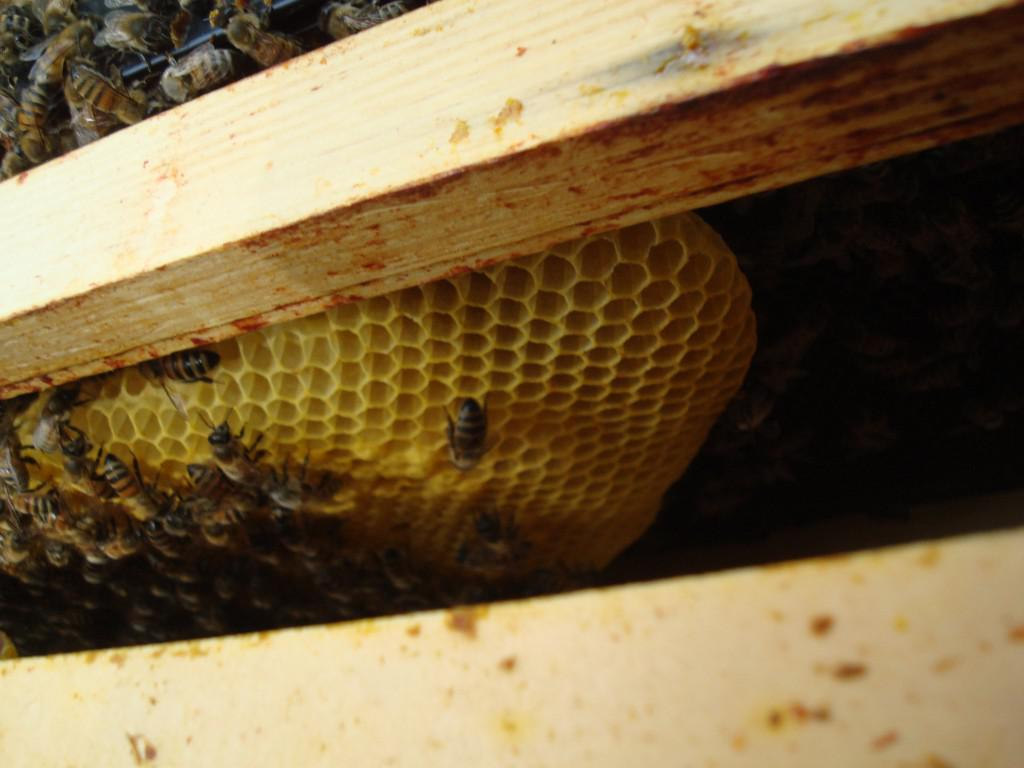What is inside the wooden box in the image? There is a beehive in the wooden box. What type of insects can be seen on the beehive? Honey bees are present on the beehive. What type of cover is placed on the church in the image? There is no church present in the image; it features a beehive in a wooden box with honey bees. 